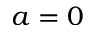Convert formula to latex. <formula><loc_0><loc_0><loc_500><loc_500>a = 0</formula> 